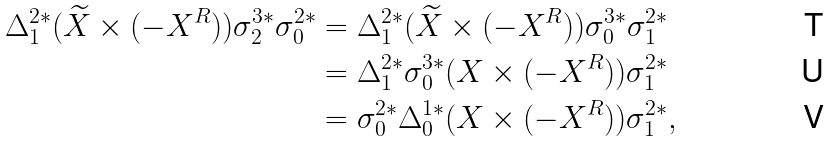<formula> <loc_0><loc_0><loc_500><loc_500>\Delta _ { 1 } ^ { 2 * } ( \widetilde { X } \times ( - X ^ { R } ) ) \sigma _ { 2 } ^ { 3 * } \sigma _ { 0 } ^ { 2 * } & = \Delta _ { 1 } ^ { 2 * } ( \widetilde { X } \times ( - X ^ { R } ) ) \sigma _ { 0 } ^ { 3 * } \sigma _ { 1 } ^ { 2 * } \\ & = \Delta _ { 1 } ^ { 2 * } \sigma _ { 0 } ^ { 3 * } ( X \times ( - X ^ { R } ) ) \sigma _ { 1 } ^ { 2 * } \\ & = \sigma _ { 0 } ^ { 2 * } \Delta _ { 0 } ^ { 1 * } ( X \times ( - X ^ { R } ) ) \sigma _ { 1 } ^ { 2 * } ,</formula> 